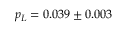Convert formula to latex. <formula><loc_0><loc_0><loc_500><loc_500>p _ { L } = 0 . 0 3 9 \pm 0 . 0 0 3</formula> 